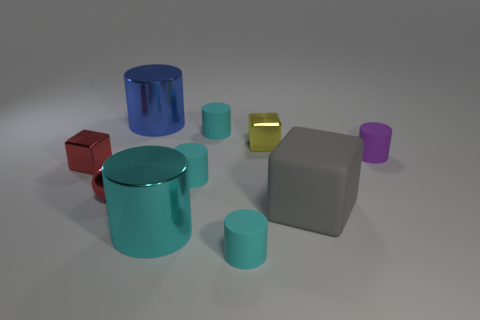How many cyan cylinders must be subtracted to get 3 cyan cylinders? 1 Subtract all small purple cylinders. How many cylinders are left? 5 Subtract all blocks. How many objects are left? 7 Subtract all blue cylinders. How many cylinders are left? 5 Subtract 2 blocks. How many blocks are left? 1 Subtract all cyan cylinders. How many gray cubes are left? 1 Add 8 large cubes. How many large cubes exist? 9 Subtract 0 yellow balls. How many objects are left? 10 Subtract all brown spheres. Subtract all brown blocks. How many spheres are left? 1 Subtract all shiny spheres. Subtract all shiny cylinders. How many objects are left? 7 